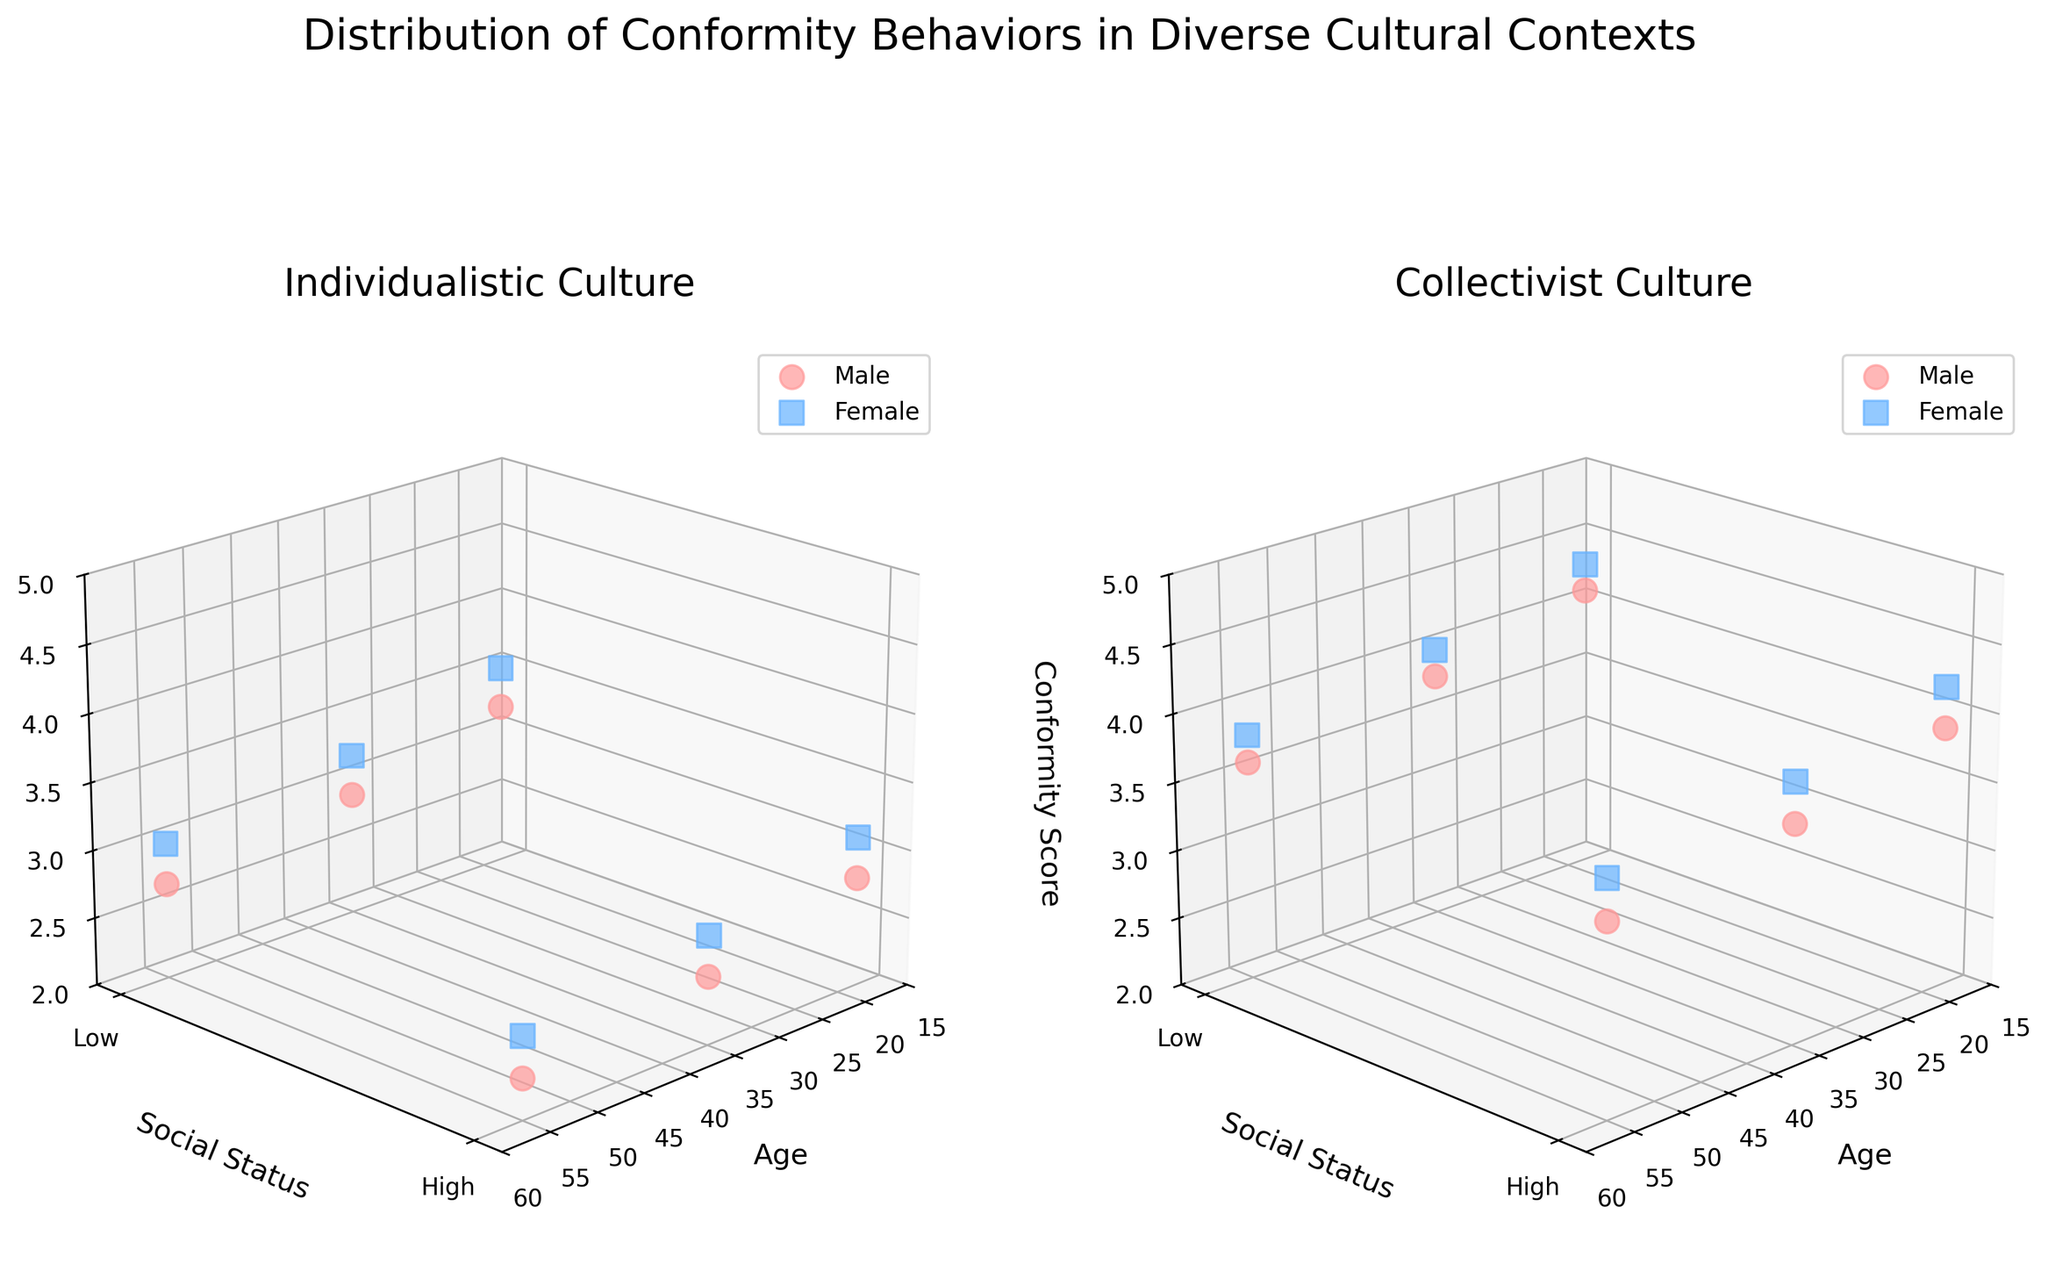What's the title of the figure? The title of the figure is presented at the top of the plot, it reads "Distribution of Conformity Behaviors in Diverse Cultural Contexts".
Answer: Distribution of Conformity Behaviors in Diverse Cultural Contexts How many 3D subplots are there in the figure? There are two separate 3D subplots side by side in the figure, each representing different cultural contexts.
Answer: Two Which gender has higher conformity scores in the Collectivist culture? By examining the data points in the subplot titled "Collectivist Culture", it is seen that the red squares (Female) are positioned higher on the Z-axis (Conformity Score) compared to the blue circles (Male).
Answer: Female What are the Y-axis labels, and what do they represent? The Y-axis has two ticks labeled "Low" and "High", representing the two levels of social status.
Answer: Low, High In the Individualistic culture, does social status affect conformity scores more in males or females? By examining the data points in the subplot titled "Individualistic Culture", the gap between conformity scores for Low and High social status appears more significant for females (larger decrease from Low to High).
Answer: Females Which age group shows the highest conformity score in the Collectivist culture? By looking at the Z-axis values in all age group data points in the Collectivist Culture subplot, the highest conformity scores appear in the age group of 18.
Answer: 18 What is the average conformity score for all data points in the Individualistic culture subplot? We calculate as follows: (3.2 + 3.5 + 2.8 + 3.1 + 2.9 + 3.2 + 2.5 + 2.8 + 2.7 + 3.0 + 2.3 + 2.6) / 12. The sum of the conformity scores is 36.6 and dividing by 12 gives 3.05.
Answer: 3.05 Compare the conformity scores for high social status males in both cultural contexts. By comparing the data points, high social status males in the Collectivist context score (3.9, 3.6, 3.4) which are higher than those in the Individualistic context who score (2.8, 2.5, 2.3).
Answer: Higher in Collectivist Which cultural context has data points with higher overall conformity scores? By scanning both subplots, the Collectivist context consistently has higher Z-axis values compared to the Individualistic context.
Answer: Collectivist What is the trend in conformity scores with age in the Individualistic culture? By observing the Z-axis values across different age groups (18, 35, 55) in the subplot titled "Individualistic Culture", the conformity scores decrease as age increases.
Answer: Decrease with age 